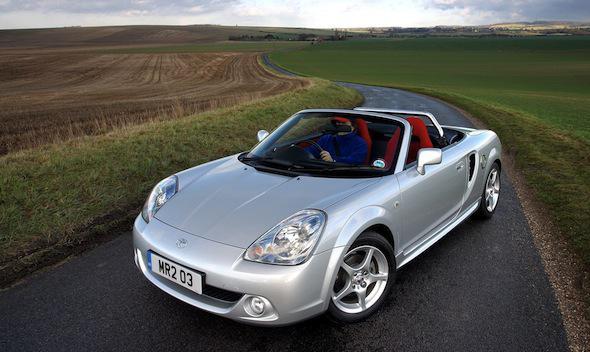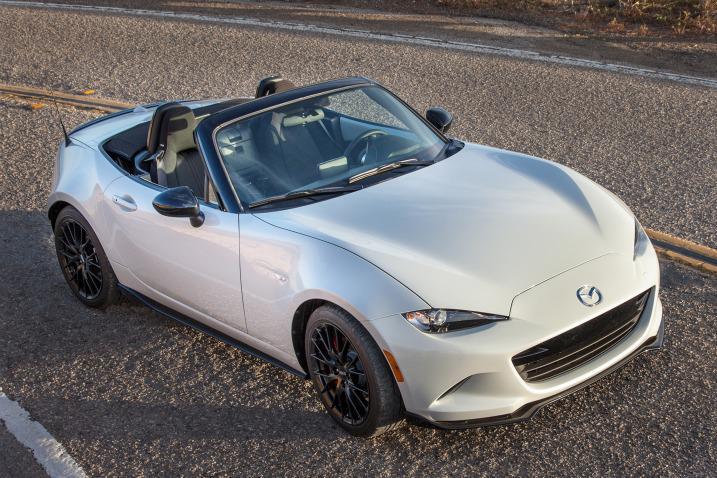The first image is the image on the left, the second image is the image on the right. Analyze the images presented: Is the assertion "Each image shows a car with its top down, and one image shows someone behind the wheel of a car." valid? Answer yes or no. Yes. The first image is the image on the left, the second image is the image on the right. Examine the images to the left and right. Is the description "Both convertibles have their tops down." accurate? Answer yes or no. Yes. 